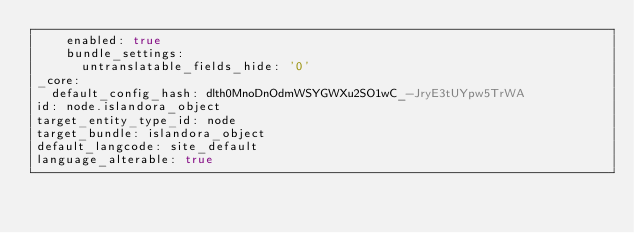Convert code to text. <code><loc_0><loc_0><loc_500><loc_500><_YAML_>    enabled: true
    bundle_settings:
      untranslatable_fields_hide: '0'
_core:
  default_config_hash: dlth0MnoDnOdmWSYGWXu2SO1wC_-JryE3tUYpw5TrWA
id: node.islandora_object
target_entity_type_id: node
target_bundle: islandora_object
default_langcode: site_default
language_alterable: true
</code> 